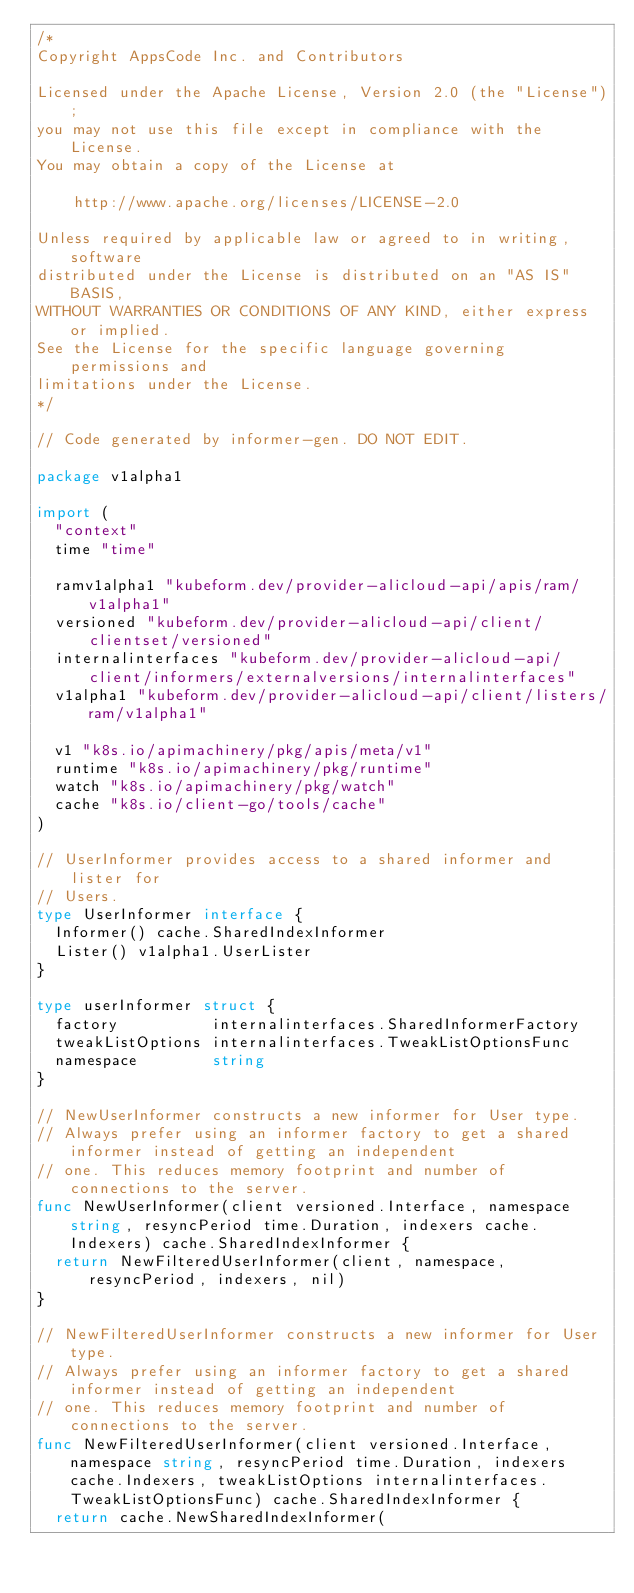Convert code to text. <code><loc_0><loc_0><loc_500><loc_500><_Go_>/*
Copyright AppsCode Inc. and Contributors

Licensed under the Apache License, Version 2.0 (the "License");
you may not use this file except in compliance with the License.
You may obtain a copy of the License at

    http://www.apache.org/licenses/LICENSE-2.0

Unless required by applicable law or agreed to in writing, software
distributed under the License is distributed on an "AS IS" BASIS,
WITHOUT WARRANTIES OR CONDITIONS OF ANY KIND, either express or implied.
See the License for the specific language governing permissions and
limitations under the License.
*/

// Code generated by informer-gen. DO NOT EDIT.

package v1alpha1

import (
	"context"
	time "time"

	ramv1alpha1 "kubeform.dev/provider-alicloud-api/apis/ram/v1alpha1"
	versioned "kubeform.dev/provider-alicloud-api/client/clientset/versioned"
	internalinterfaces "kubeform.dev/provider-alicloud-api/client/informers/externalversions/internalinterfaces"
	v1alpha1 "kubeform.dev/provider-alicloud-api/client/listers/ram/v1alpha1"

	v1 "k8s.io/apimachinery/pkg/apis/meta/v1"
	runtime "k8s.io/apimachinery/pkg/runtime"
	watch "k8s.io/apimachinery/pkg/watch"
	cache "k8s.io/client-go/tools/cache"
)

// UserInformer provides access to a shared informer and lister for
// Users.
type UserInformer interface {
	Informer() cache.SharedIndexInformer
	Lister() v1alpha1.UserLister
}

type userInformer struct {
	factory          internalinterfaces.SharedInformerFactory
	tweakListOptions internalinterfaces.TweakListOptionsFunc
	namespace        string
}

// NewUserInformer constructs a new informer for User type.
// Always prefer using an informer factory to get a shared informer instead of getting an independent
// one. This reduces memory footprint and number of connections to the server.
func NewUserInformer(client versioned.Interface, namespace string, resyncPeriod time.Duration, indexers cache.Indexers) cache.SharedIndexInformer {
	return NewFilteredUserInformer(client, namespace, resyncPeriod, indexers, nil)
}

// NewFilteredUserInformer constructs a new informer for User type.
// Always prefer using an informer factory to get a shared informer instead of getting an independent
// one. This reduces memory footprint and number of connections to the server.
func NewFilteredUserInformer(client versioned.Interface, namespace string, resyncPeriod time.Duration, indexers cache.Indexers, tweakListOptions internalinterfaces.TweakListOptionsFunc) cache.SharedIndexInformer {
	return cache.NewSharedIndexInformer(</code> 